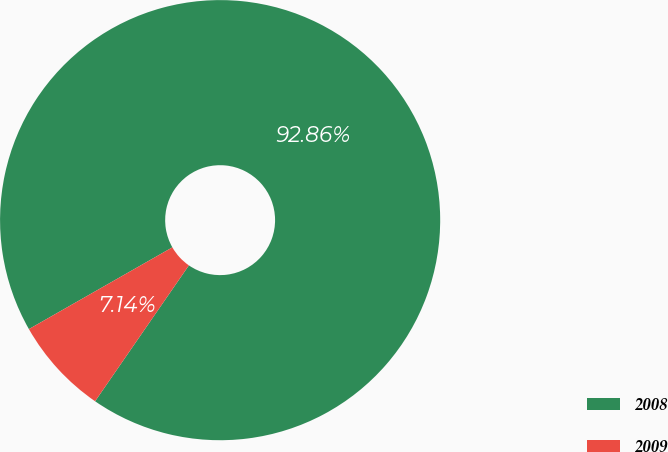Convert chart to OTSL. <chart><loc_0><loc_0><loc_500><loc_500><pie_chart><fcel>2008<fcel>2009<nl><fcel>92.86%<fcel>7.14%<nl></chart> 